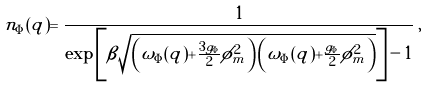<formula> <loc_0><loc_0><loc_500><loc_500>n _ { \Phi } ( { q } ) = \frac { 1 } { \exp \left [ \beta \sqrt { \left ( \omega _ { \Phi } ( { q } ) + \frac { 3 g _ { \Phi } } { 2 } \phi _ { m } ^ { 2 } \right ) \left ( \omega _ { \Phi } ( { q } ) + \frac { g _ { \Phi } } { 2 } \phi _ { m } ^ { 2 } \right ) } \right ] - 1 } \, ,</formula> 